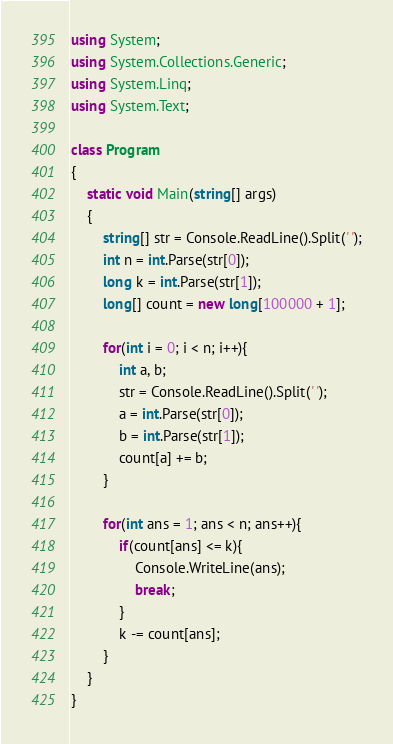<code> <loc_0><loc_0><loc_500><loc_500><_C#_>using System;
using System.Collections.Generic;
using System.Linq;
using System.Text;

class Program
{
    static void Main(string[] args)
    {
        string[] str = Console.ReadLine().Split(' ');
        int n = int.Parse(str[0]);
        long k = int.Parse(str[1]);
        long[] count = new long[100000 + 1];

        for(int i = 0; i < n; i++){
            int a, b;
            str = Console.ReadLine().Split(' ');
            a = int.Parse(str[0]);
            b = int.Parse(str[1]);
            count[a] += b;
        }

        for(int ans = 1; ans < n; ans++){
            if(count[ans] <= k){
                Console.WriteLine(ans);
                break;
            }
            k -= count[ans];
        }
    }
}</code> 